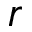Convert formula to latex. <formula><loc_0><loc_0><loc_500><loc_500>r</formula> 